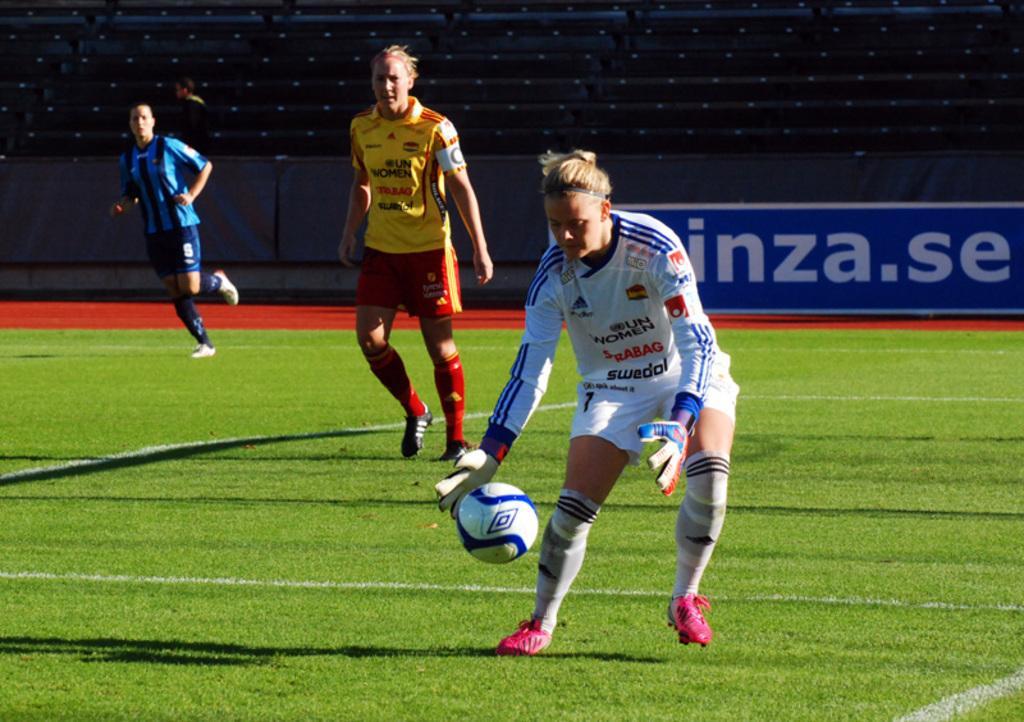Can you describe this image briefly? In this image we can see a stadium. There is a soccer ground in the image. The players are playing in the image. There is a football in the image. There is an advertising board in the image. 